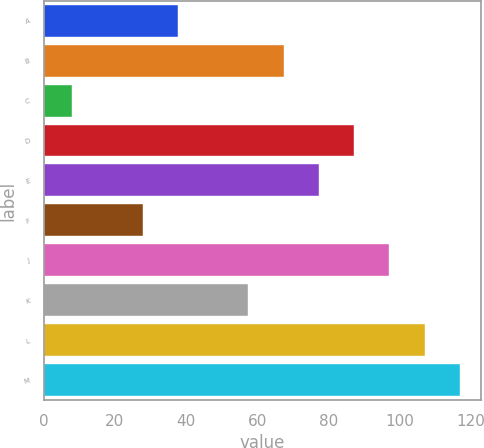Convert chart to OTSL. <chart><loc_0><loc_0><loc_500><loc_500><bar_chart><fcel>A<fcel>B<fcel>C<fcel>D<fcel>E<fcel>F<fcel>J<fcel>K<fcel>L<fcel>M<nl><fcel>37.7<fcel>67.4<fcel>8<fcel>87.2<fcel>77.3<fcel>27.8<fcel>97.1<fcel>57.5<fcel>107<fcel>116.9<nl></chart> 